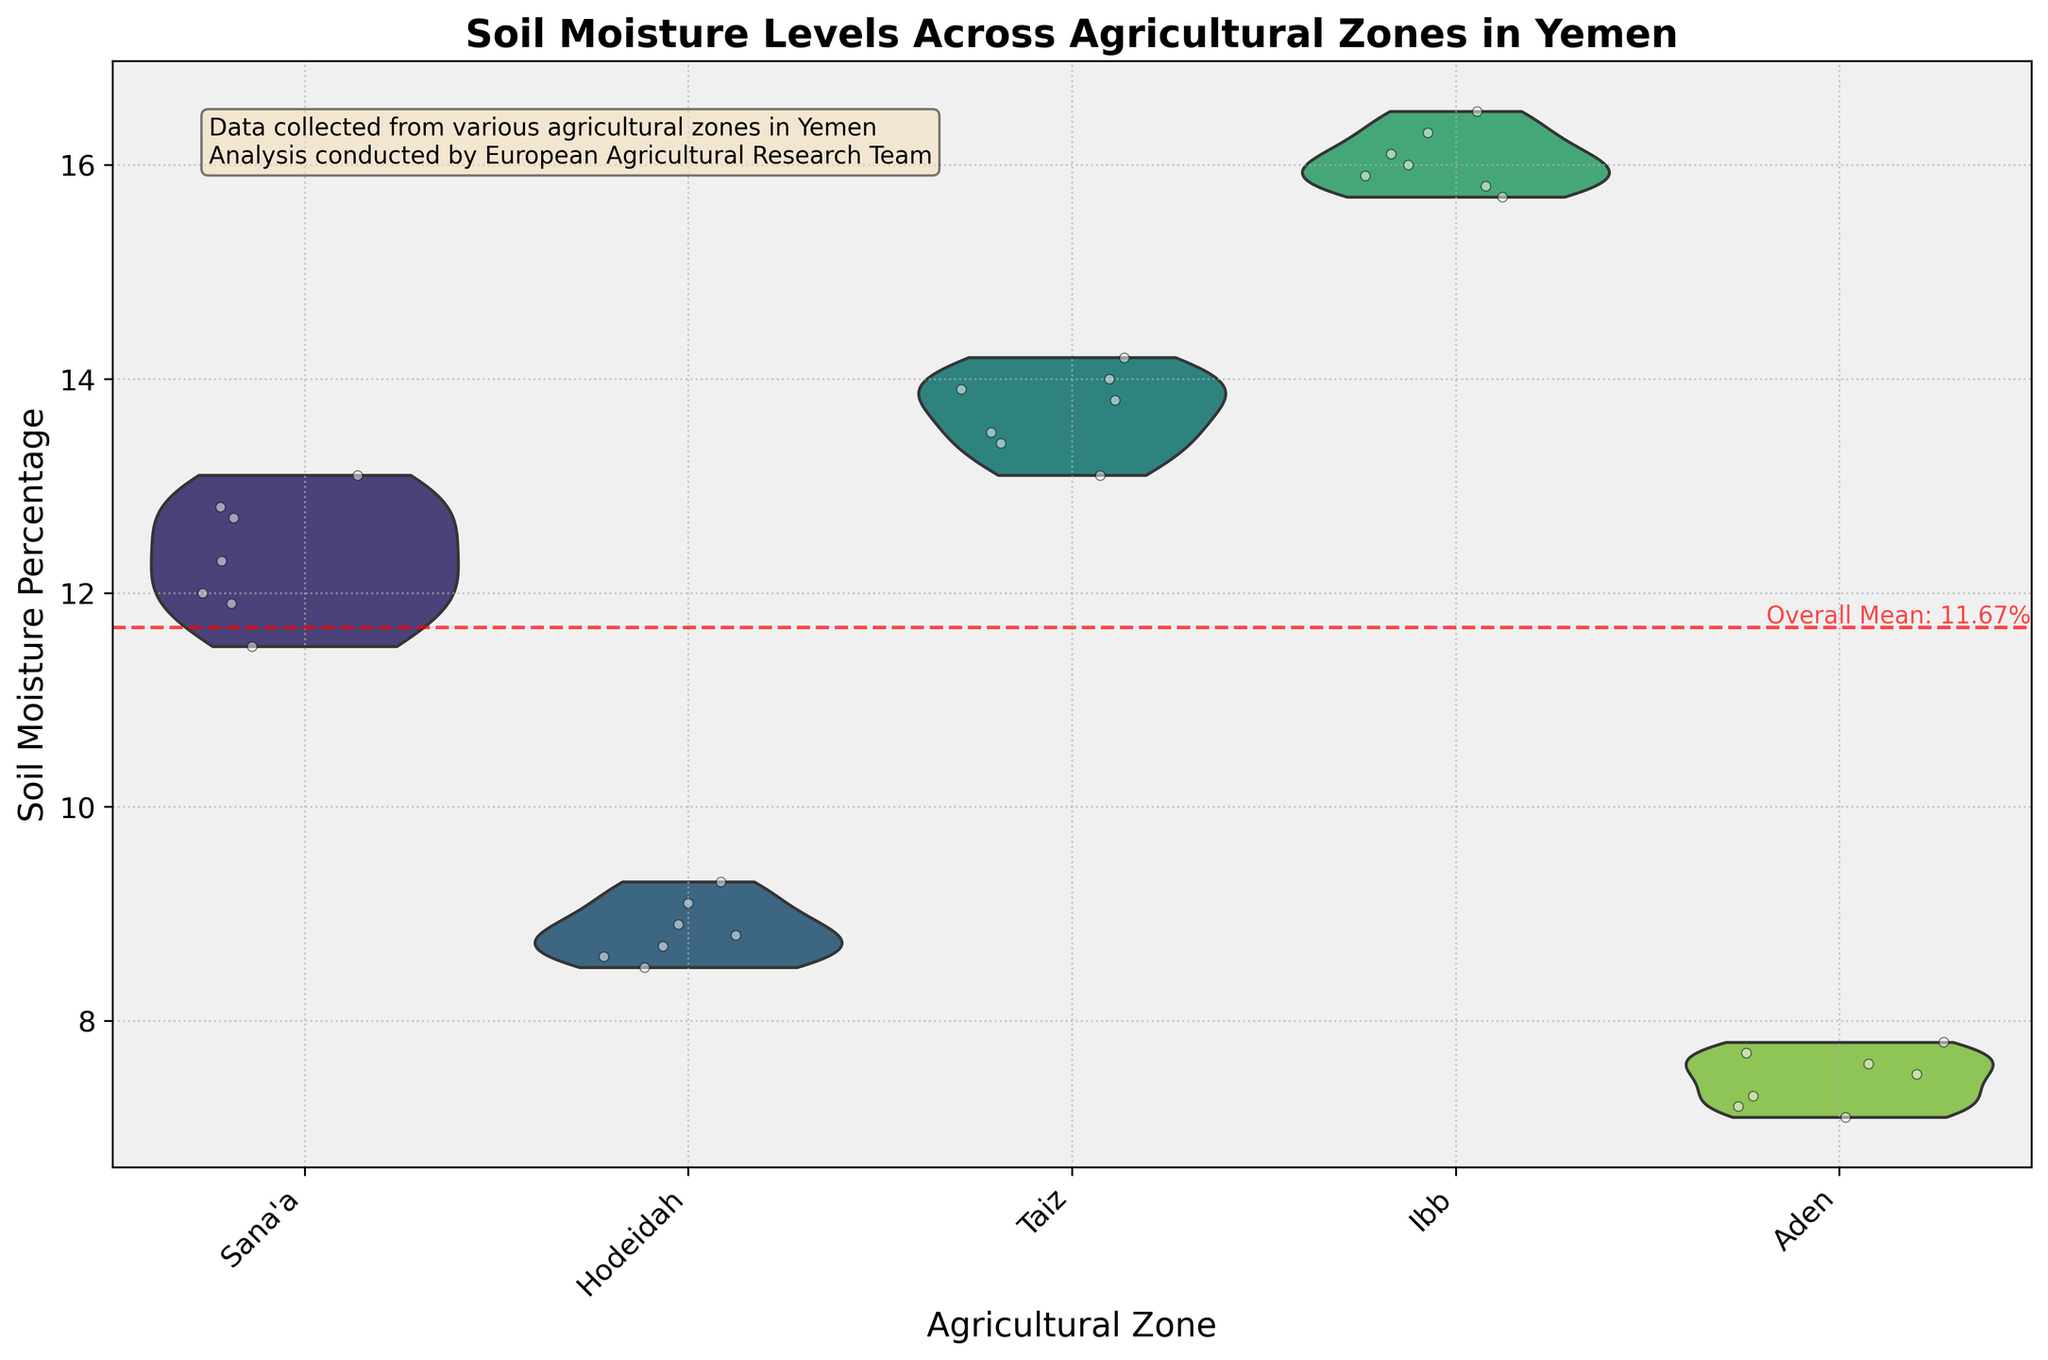What is the title of the figure? The title is located at the top of the figure and is usually in a larger and bold font. The title provides an overarching description of what the figure represents.
Answer: Soil Moisture Levels Across Agricultural Zones in Yemen Which agricultural zone has the highest soil moisture level? The highest soil moisture level is indicated by the uppermost point in the violin plot. By observing the topmost points across all zones, the highest soil moisture level can be determined.
Answer: Ibb What is the general trend in soil moisture levels across the agricultural zones? To identify the general trend, observe the spread and the central tendency of the data within the violin plots for each zone.
Answer: Ibb has the highest moisture levels, followed by Taiz, Sana'a, Hodeidah, and Aden How many agricultural zones are represented in the figure? The number of agricultural zones can be counted by identifying the distinct groups along the x-axis. Each unique label corresponds to an agricultural zone.
Answer: 5 Which zone has the lowest median soil moisture percentage? The median is typically represented by the thicker area in the middle of the violin plot. Comparing the middle sections of each plot can reveal the zone with the lowest median value.
Answer: Aden What is the overall mean soil moisture percentage, and how is it indicated in the figure? The overall mean is often marked by a horizontal line across the entire plot. Observing the horizontal line and accompanying text can provide this information.
Answer: 11.89% Is the variation in soil moisture levels higher in Ibb or Hodeidah? The variation in soil moisture levels can be interpreted by the width and spread of the violin plots. Wider plots with more spread-out points indicate higher variation.
Answer: Ibb Between Sana'a and Taiz, which zone shows a greater range in soil moisture levels? The range is determined by the difference between the maximum and minimum values depicted in the violin plots. Comparing the vertical span of the plots gives the answer.
Answer: Taiz Describe the distribution of soil moisture levels in Aden. The distribution can be interpreted by the shape and spread of the violin plot, along with the jittered points which show individual data values.
Answer: Narrow with a low median around 7.3% - 7.8% What additional information is provided in the text box within the figure? The text box often contains contextual and supplementary information related to the figure. Reading the contents of the box provides this info.
Answer: Data collected from various agricultural zones in Yemen; Analysis conducted by European Agricultural Research Team 